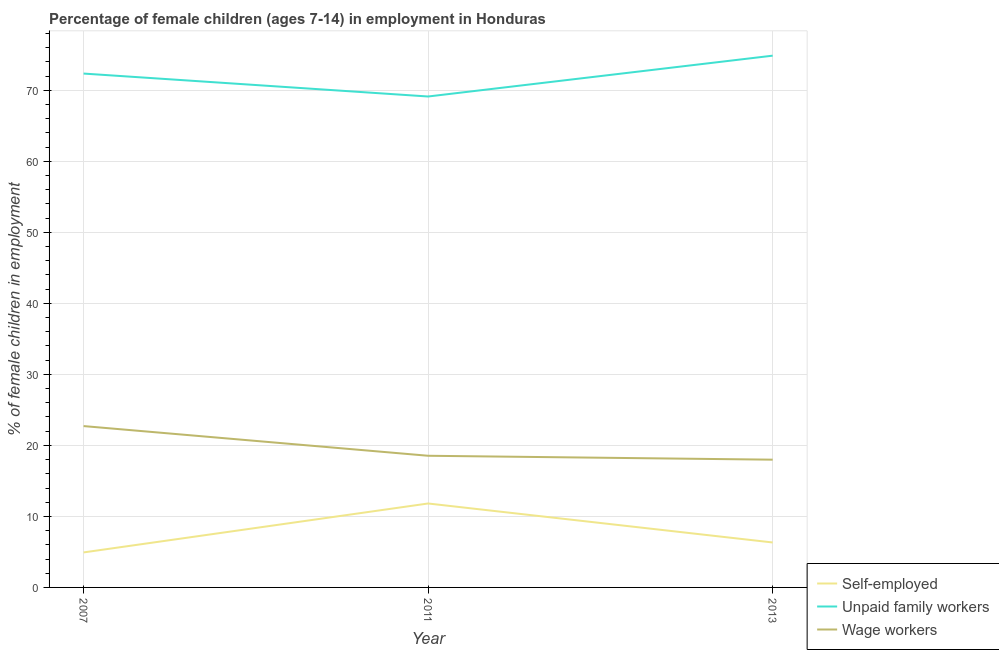How many different coloured lines are there?
Your answer should be compact. 3. Is the number of lines equal to the number of legend labels?
Your answer should be very brief. Yes. What is the percentage of self employed children in 2013?
Ensure brevity in your answer.  6.33. Across all years, what is the maximum percentage of self employed children?
Offer a very short reply. 11.82. Across all years, what is the minimum percentage of children employed as wage workers?
Your answer should be compact. 17.99. What is the total percentage of children employed as wage workers in the graph?
Your answer should be very brief. 59.25. What is the difference between the percentage of children employed as wage workers in 2007 and that in 2013?
Your answer should be compact. 4.73. What is the difference between the percentage of children employed as unpaid family workers in 2007 and the percentage of children employed as wage workers in 2011?
Ensure brevity in your answer.  53.82. What is the average percentage of self employed children per year?
Your answer should be compact. 7.69. In the year 2007, what is the difference between the percentage of children employed as unpaid family workers and percentage of children employed as wage workers?
Keep it short and to the point. 49.64. In how many years, is the percentage of children employed as wage workers greater than 46 %?
Offer a very short reply. 0. What is the ratio of the percentage of self employed children in 2011 to that in 2013?
Ensure brevity in your answer.  1.87. Is the percentage of children employed as unpaid family workers in 2007 less than that in 2013?
Keep it short and to the point. Yes. What is the difference between the highest and the second highest percentage of self employed children?
Provide a short and direct response. 5.49. What is the difference between the highest and the lowest percentage of self employed children?
Offer a terse response. 6.89. How many lines are there?
Your response must be concise. 3. What is the difference between two consecutive major ticks on the Y-axis?
Keep it short and to the point. 10. Are the values on the major ticks of Y-axis written in scientific E-notation?
Your answer should be very brief. No. Does the graph contain any zero values?
Your answer should be compact. No. How many legend labels are there?
Provide a short and direct response. 3. What is the title of the graph?
Give a very brief answer. Percentage of female children (ages 7-14) in employment in Honduras. Does "Nuclear sources" appear as one of the legend labels in the graph?
Provide a short and direct response. No. What is the label or title of the X-axis?
Your response must be concise. Year. What is the label or title of the Y-axis?
Provide a short and direct response. % of female children in employment. What is the % of female children in employment of Self-employed in 2007?
Provide a succinct answer. 4.93. What is the % of female children in employment of Unpaid family workers in 2007?
Keep it short and to the point. 72.36. What is the % of female children in employment of Wage workers in 2007?
Your response must be concise. 22.72. What is the % of female children in employment of Self-employed in 2011?
Keep it short and to the point. 11.82. What is the % of female children in employment in Unpaid family workers in 2011?
Provide a short and direct response. 69.13. What is the % of female children in employment of Wage workers in 2011?
Offer a terse response. 18.54. What is the % of female children in employment of Self-employed in 2013?
Your answer should be compact. 6.33. What is the % of female children in employment of Unpaid family workers in 2013?
Your answer should be very brief. 74.88. What is the % of female children in employment in Wage workers in 2013?
Make the answer very short. 17.99. Across all years, what is the maximum % of female children in employment in Self-employed?
Provide a short and direct response. 11.82. Across all years, what is the maximum % of female children in employment of Unpaid family workers?
Offer a terse response. 74.88. Across all years, what is the maximum % of female children in employment in Wage workers?
Your answer should be compact. 22.72. Across all years, what is the minimum % of female children in employment of Self-employed?
Your answer should be compact. 4.93. Across all years, what is the minimum % of female children in employment of Unpaid family workers?
Provide a short and direct response. 69.13. Across all years, what is the minimum % of female children in employment in Wage workers?
Ensure brevity in your answer.  17.99. What is the total % of female children in employment in Self-employed in the graph?
Keep it short and to the point. 23.08. What is the total % of female children in employment of Unpaid family workers in the graph?
Offer a terse response. 216.37. What is the total % of female children in employment in Wage workers in the graph?
Make the answer very short. 59.25. What is the difference between the % of female children in employment of Self-employed in 2007 and that in 2011?
Provide a succinct answer. -6.89. What is the difference between the % of female children in employment of Unpaid family workers in 2007 and that in 2011?
Your answer should be very brief. 3.23. What is the difference between the % of female children in employment in Wage workers in 2007 and that in 2011?
Your answer should be very brief. 4.18. What is the difference between the % of female children in employment in Self-employed in 2007 and that in 2013?
Offer a very short reply. -1.4. What is the difference between the % of female children in employment of Unpaid family workers in 2007 and that in 2013?
Provide a short and direct response. -2.52. What is the difference between the % of female children in employment in Wage workers in 2007 and that in 2013?
Offer a very short reply. 4.73. What is the difference between the % of female children in employment in Self-employed in 2011 and that in 2013?
Make the answer very short. 5.49. What is the difference between the % of female children in employment of Unpaid family workers in 2011 and that in 2013?
Ensure brevity in your answer.  -5.75. What is the difference between the % of female children in employment of Wage workers in 2011 and that in 2013?
Offer a very short reply. 0.55. What is the difference between the % of female children in employment in Self-employed in 2007 and the % of female children in employment in Unpaid family workers in 2011?
Your answer should be very brief. -64.2. What is the difference between the % of female children in employment in Self-employed in 2007 and the % of female children in employment in Wage workers in 2011?
Your response must be concise. -13.61. What is the difference between the % of female children in employment in Unpaid family workers in 2007 and the % of female children in employment in Wage workers in 2011?
Ensure brevity in your answer.  53.82. What is the difference between the % of female children in employment in Self-employed in 2007 and the % of female children in employment in Unpaid family workers in 2013?
Offer a terse response. -69.95. What is the difference between the % of female children in employment in Self-employed in 2007 and the % of female children in employment in Wage workers in 2013?
Give a very brief answer. -13.06. What is the difference between the % of female children in employment in Unpaid family workers in 2007 and the % of female children in employment in Wage workers in 2013?
Provide a short and direct response. 54.37. What is the difference between the % of female children in employment of Self-employed in 2011 and the % of female children in employment of Unpaid family workers in 2013?
Your answer should be very brief. -63.06. What is the difference between the % of female children in employment of Self-employed in 2011 and the % of female children in employment of Wage workers in 2013?
Your response must be concise. -6.17. What is the difference between the % of female children in employment in Unpaid family workers in 2011 and the % of female children in employment in Wage workers in 2013?
Offer a very short reply. 51.14. What is the average % of female children in employment in Self-employed per year?
Your response must be concise. 7.69. What is the average % of female children in employment in Unpaid family workers per year?
Provide a succinct answer. 72.12. What is the average % of female children in employment of Wage workers per year?
Your answer should be very brief. 19.75. In the year 2007, what is the difference between the % of female children in employment in Self-employed and % of female children in employment in Unpaid family workers?
Provide a succinct answer. -67.43. In the year 2007, what is the difference between the % of female children in employment in Self-employed and % of female children in employment in Wage workers?
Give a very brief answer. -17.79. In the year 2007, what is the difference between the % of female children in employment in Unpaid family workers and % of female children in employment in Wage workers?
Ensure brevity in your answer.  49.64. In the year 2011, what is the difference between the % of female children in employment in Self-employed and % of female children in employment in Unpaid family workers?
Make the answer very short. -57.31. In the year 2011, what is the difference between the % of female children in employment of Self-employed and % of female children in employment of Wage workers?
Offer a terse response. -6.72. In the year 2011, what is the difference between the % of female children in employment of Unpaid family workers and % of female children in employment of Wage workers?
Your response must be concise. 50.59. In the year 2013, what is the difference between the % of female children in employment in Self-employed and % of female children in employment in Unpaid family workers?
Your response must be concise. -68.55. In the year 2013, what is the difference between the % of female children in employment of Self-employed and % of female children in employment of Wage workers?
Your answer should be very brief. -11.66. In the year 2013, what is the difference between the % of female children in employment in Unpaid family workers and % of female children in employment in Wage workers?
Keep it short and to the point. 56.89. What is the ratio of the % of female children in employment in Self-employed in 2007 to that in 2011?
Keep it short and to the point. 0.42. What is the ratio of the % of female children in employment of Unpaid family workers in 2007 to that in 2011?
Keep it short and to the point. 1.05. What is the ratio of the % of female children in employment of Wage workers in 2007 to that in 2011?
Keep it short and to the point. 1.23. What is the ratio of the % of female children in employment in Self-employed in 2007 to that in 2013?
Give a very brief answer. 0.78. What is the ratio of the % of female children in employment in Unpaid family workers in 2007 to that in 2013?
Ensure brevity in your answer.  0.97. What is the ratio of the % of female children in employment of Wage workers in 2007 to that in 2013?
Your answer should be compact. 1.26. What is the ratio of the % of female children in employment in Self-employed in 2011 to that in 2013?
Your answer should be very brief. 1.87. What is the ratio of the % of female children in employment of Unpaid family workers in 2011 to that in 2013?
Make the answer very short. 0.92. What is the ratio of the % of female children in employment in Wage workers in 2011 to that in 2013?
Give a very brief answer. 1.03. What is the difference between the highest and the second highest % of female children in employment of Self-employed?
Offer a terse response. 5.49. What is the difference between the highest and the second highest % of female children in employment in Unpaid family workers?
Your answer should be compact. 2.52. What is the difference between the highest and the second highest % of female children in employment of Wage workers?
Your answer should be compact. 4.18. What is the difference between the highest and the lowest % of female children in employment in Self-employed?
Give a very brief answer. 6.89. What is the difference between the highest and the lowest % of female children in employment of Unpaid family workers?
Give a very brief answer. 5.75. What is the difference between the highest and the lowest % of female children in employment in Wage workers?
Provide a succinct answer. 4.73. 